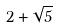<formula> <loc_0><loc_0><loc_500><loc_500>2 + \sqrt { 5 }</formula> 